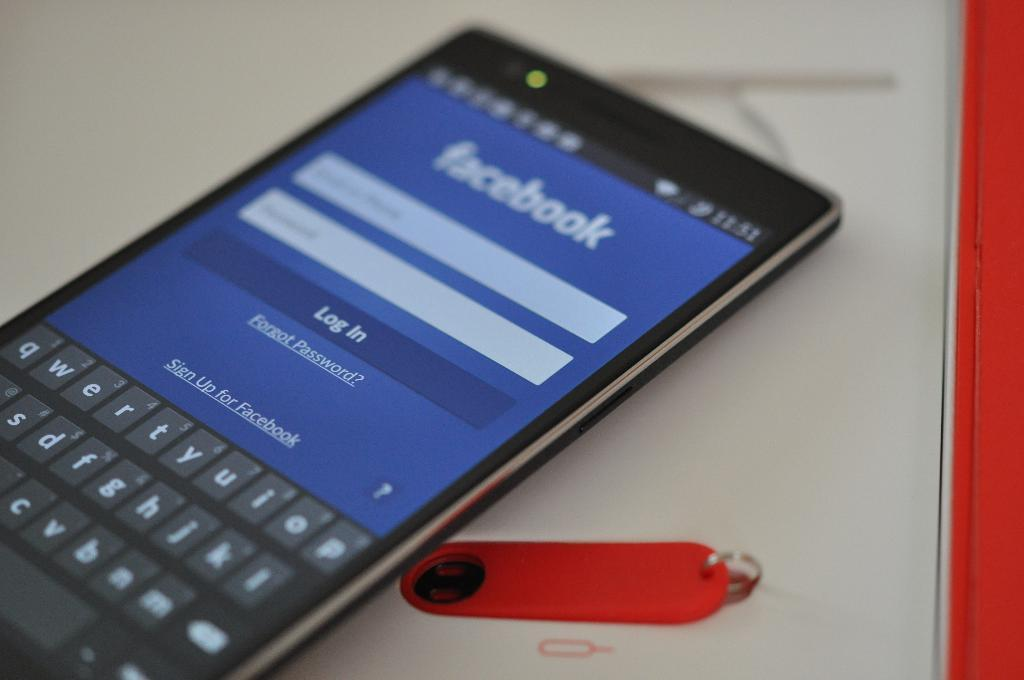Provide a one-sentence caption for the provided image. a cell phone with a facebook screen open on the home screen. 